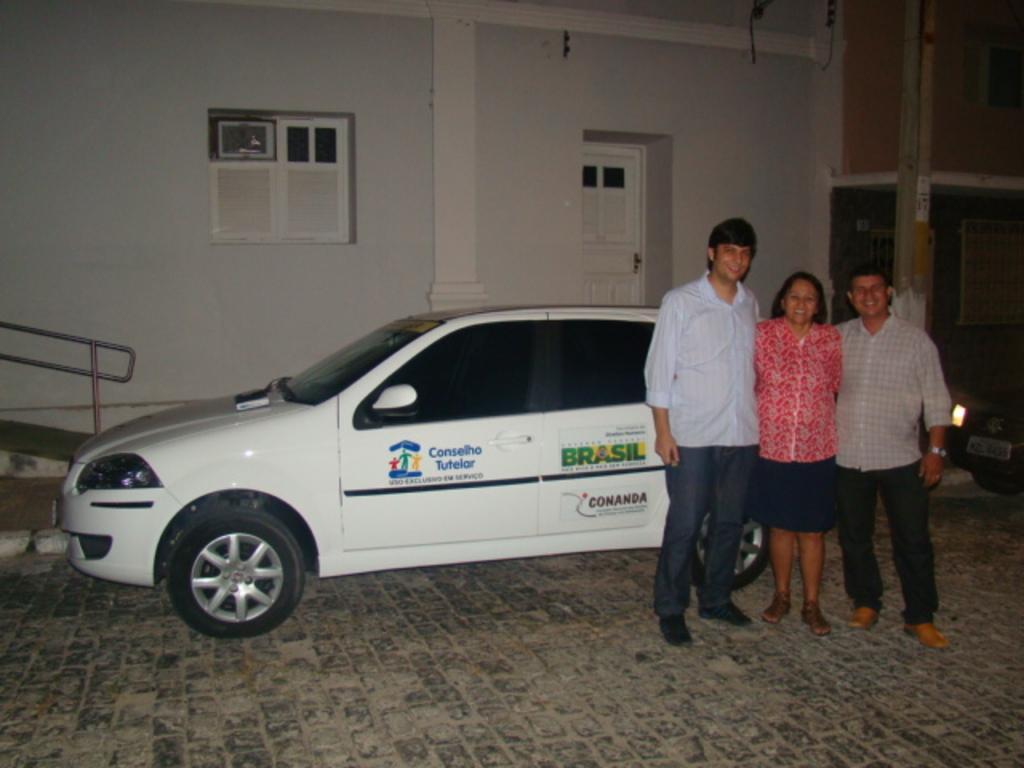In one or two sentences, can you explain what this image depicts? On the right side of the image, we can see three people are standing side by side on the surface. They are watching and smiling. Background we can see vehicles, walls, windows, door, pillars and rods. 